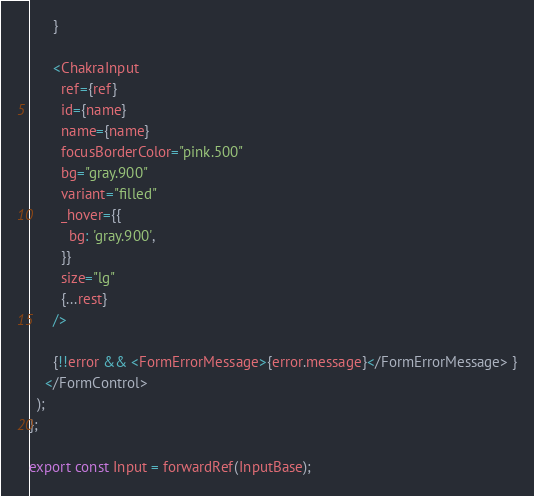<code> <loc_0><loc_0><loc_500><loc_500><_TypeScript_>      }

      <ChakraInput
        ref={ref}
        id={name}
        name={name}
        focusBorderColor="pink.500"
        bg="gray.900"
        variant="filled"
        _hover={{
          bg: 'gray.900',
        }}
        size="lg"
        {...rest}
      />

      {!!error && <FormErrorMessage>{error.message}</FormErrorMessage> }
    </FormControl>
  );
};

export const Input = forwardRef(InputBase);
</code> 